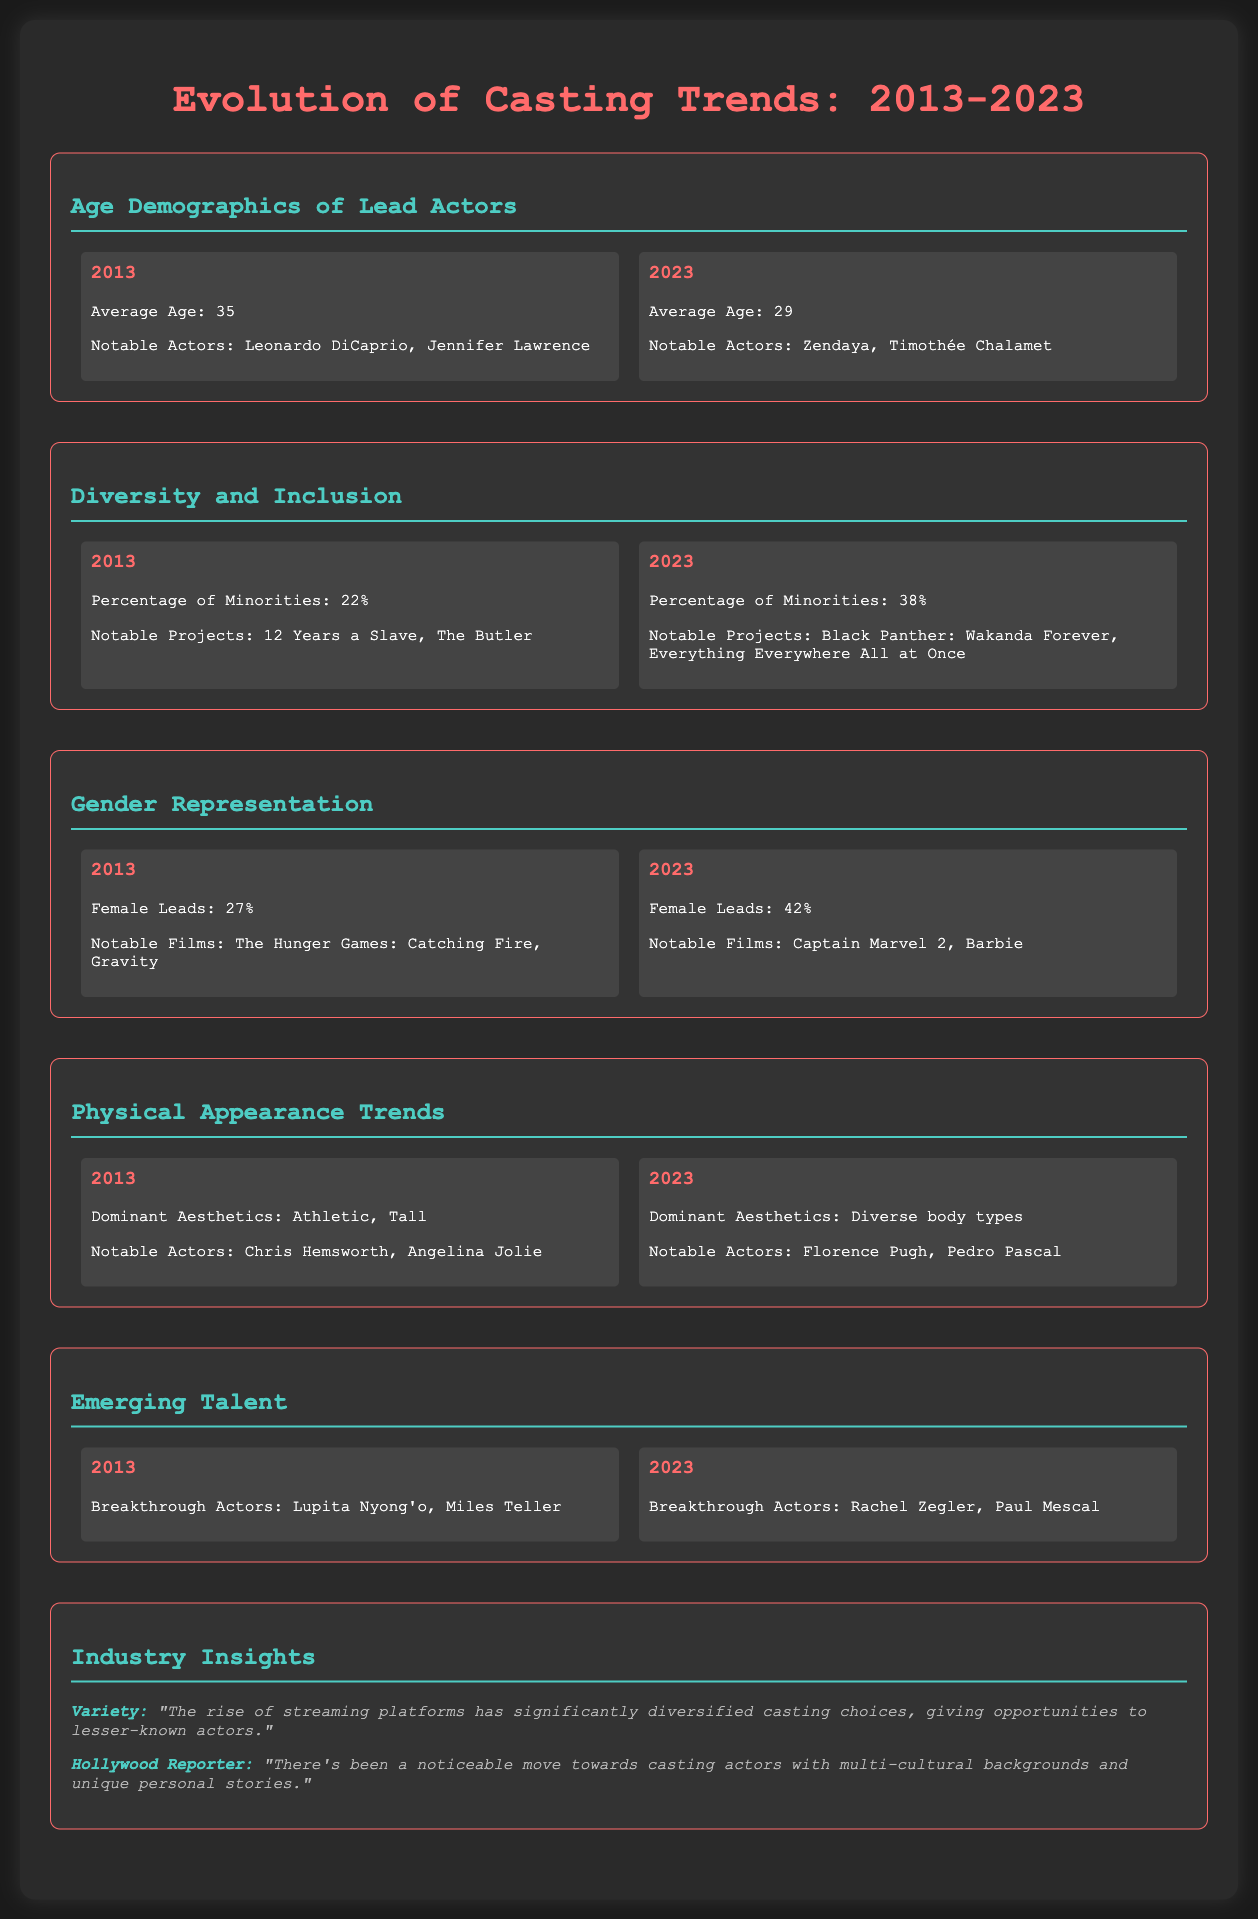What was the average age of lead actors in 2013? The average age of lead actors in 2013 is mentioned in the document as 35.
Answer: 35 What notable actors are listed for 2023? The document highlights Zendaya and Timothée Chalamet as notable actors for 2023.
Answer: Zendaya, Timothée Chalamet What percentage of minorities was represented in 2013? The document states that the percentage of minorities in 2013 was 22%.
Answer: 22% What was the female lead percentage in 2023? The document indicates that female leads constituted 42% in 2023.
Answer: 42% Which actor is mentioned as a breakthrough talent in 2023? According to the document, Rachel Zegler is noted as a breakthrough actor in 2023.
Answer: Rachel Zegler What source mentioned the rise of streaming platforms affecting casting? The document attributes the comment on streaming platforms to Variety.
Answer: Variety Identify a notable project from 2013 related to diversity. The notable project mentioned for 2013 is "12 Years a Slave."
Answer: 12 Years a Slave What is the key trend in gender representation from 2013 to 2023? The document shows a growth in female leads from 27% in 2013 to 42% in 2023, indicating increased representation.
Answer: Increased representation 